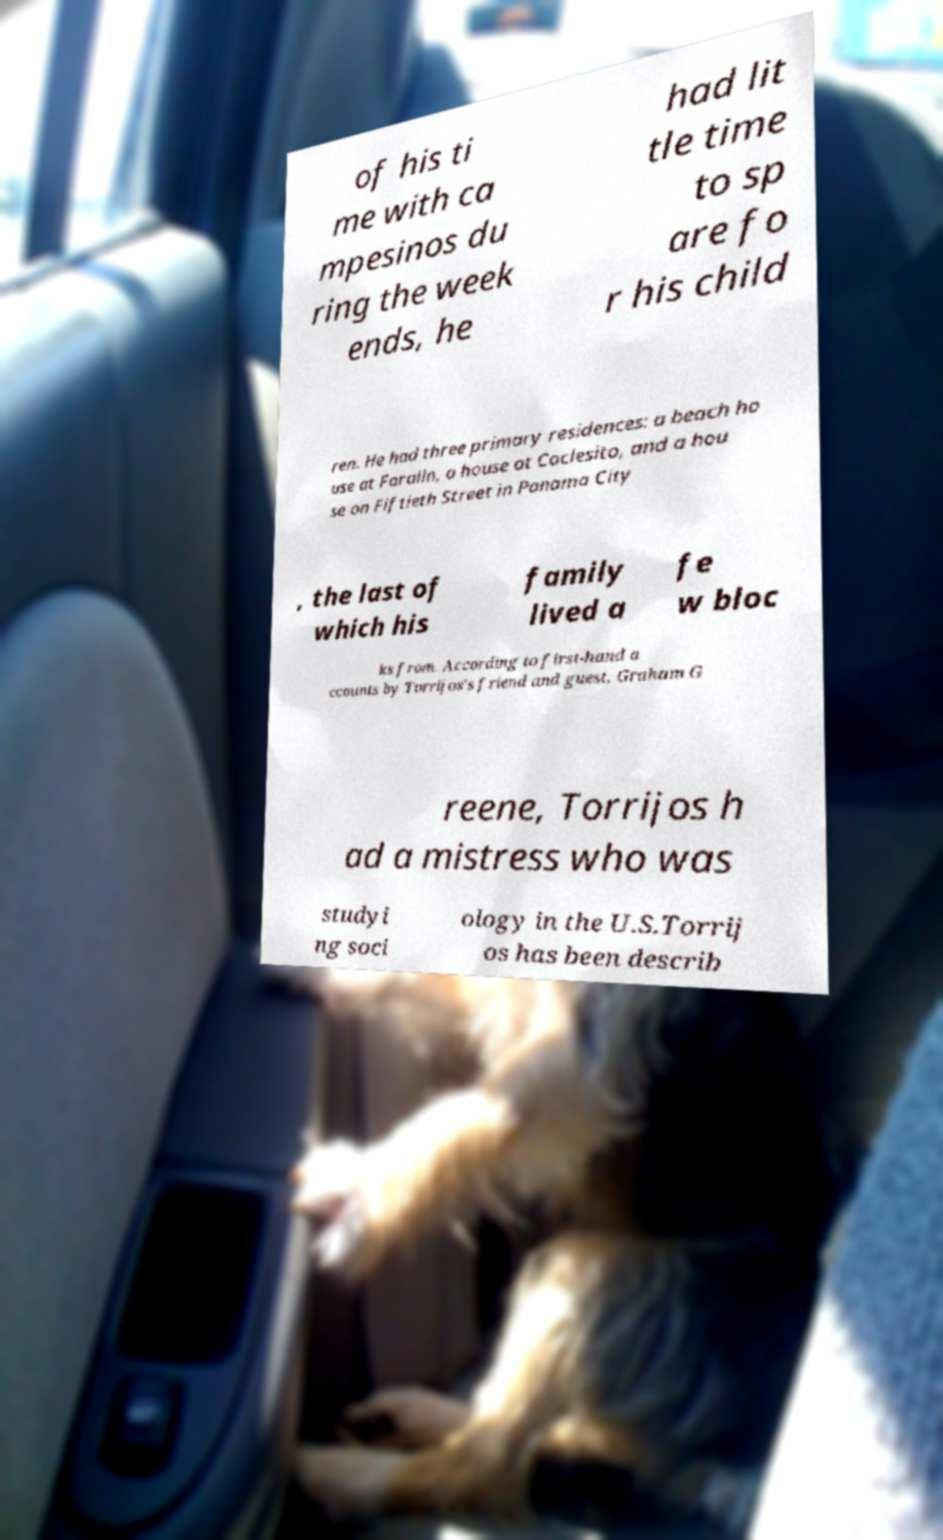For documentation purposes, I need the text within this image transcribed. Could you provide that? of his ti me with ca mpesinos du ring the week ends, he had lit tle time to sp are fo r his child ren. He had three primary residences: a beach ho use at Faralln, a house at Coclesito, and a hou se on Fiftieth Street in Panama City , the last of which his family lived a fe w bloc ks from. According to first-hand a ccounts by Torrijos's friend and guest, Graham G reene, Torrijos h ad a mistress who was studyi ng soci ology in the U.S.Torrij os has been describ 